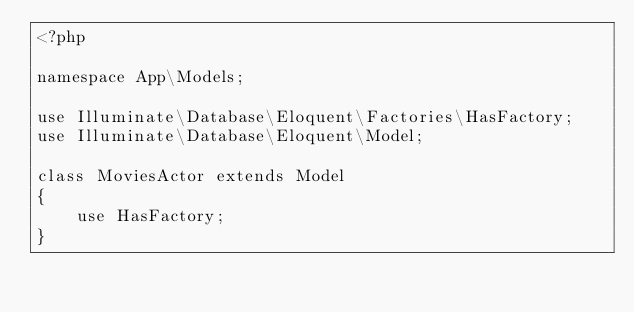Convert code to text. <code><loc_0><loc_0><loc_500><loc_500><_PHP_><?php

namespace App\Models;

use Illuminate\Database\Eloquent\Factories\HasFactory;
use Illuminate\Database\Eloquent\Model;

class MoviesActor extends Model
{
    use HasFactory;
}
</code> 